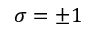Convert formula to latex. <formula><loc_0><loc_0><loc_500><loc_500>\sigma = \pm 1</formula> 